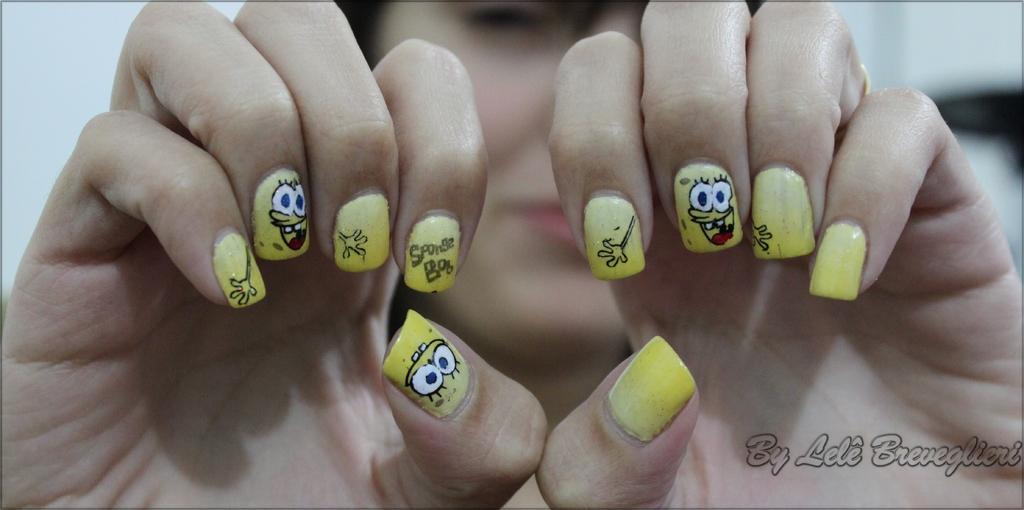In one or two sentences, can you explain what this image depicts? This image consists of a woman. There are nails in this image. 